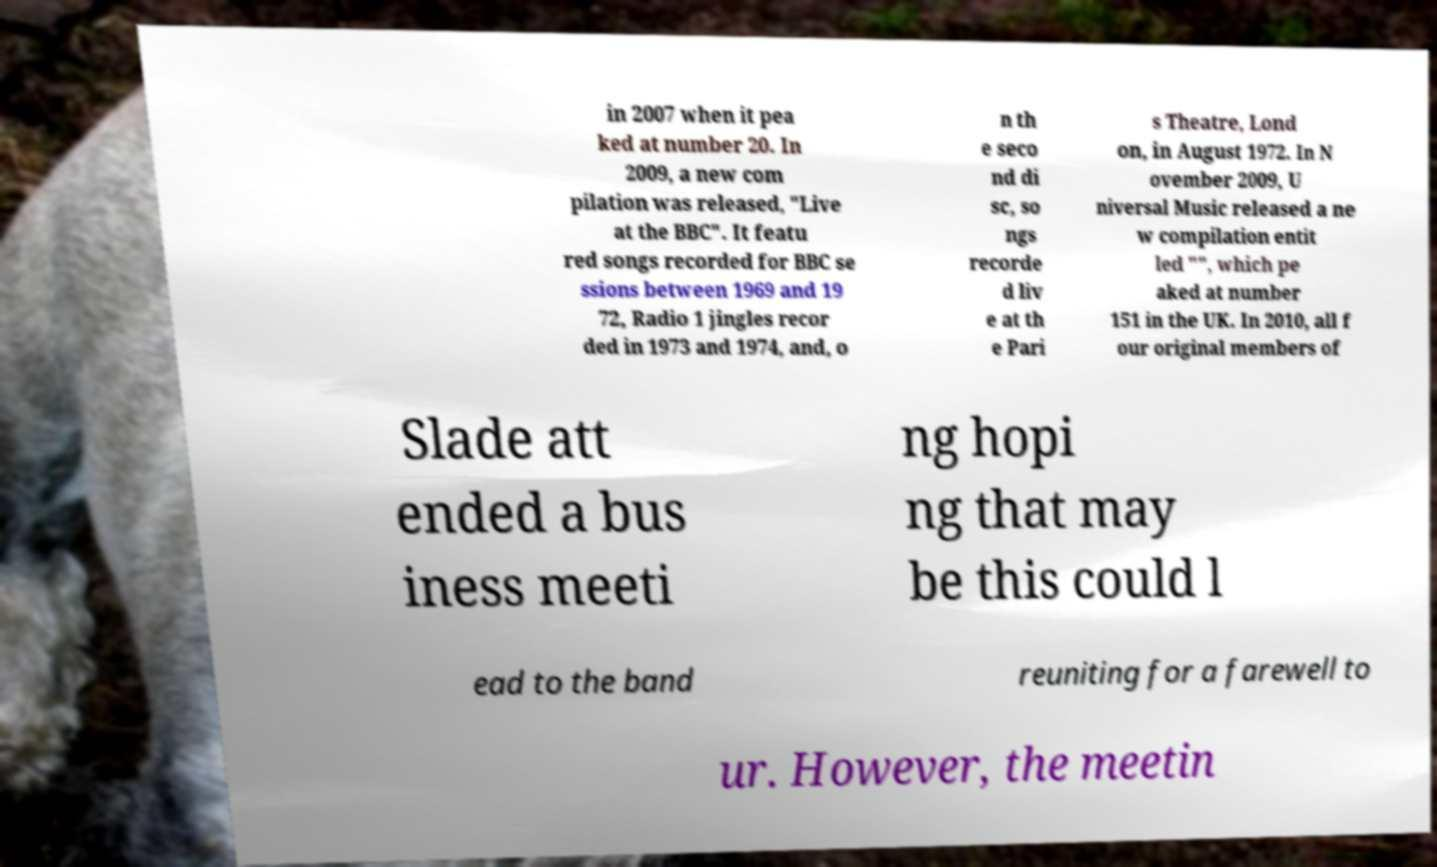Please identify and transcribe the text found in this image. in 2007 when it pea ked at number 20. In 2009, a new com pilation was released, "Live at the BBC". It featu red songs recorded for BBC se ssions between 1969 and 19 72, Radio 1 jingles recor ded in 1973 and 1974, and, o n th e seco nd di sc, so ngs recorde d liv e at th e Pari s Theatre, Lond on, in August 1972. In N ovember 2009, U niversal Music released a ne w compilation entit led "", which pe aked at number 151 in the UK. In 2010, all f our original members of Slade att ended a bus iness meeti ng hopi ng that may be this could l ead to the band reuniting for a farewell to ur. However, the meetin 